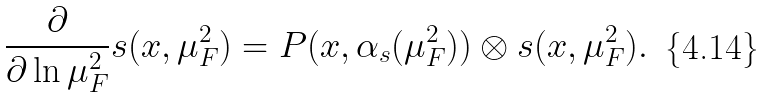Convert formula to latex. <formula><loc_0><loc_0><loc_500><loc_500>\frac { \partial } { \partial \ln \mu _ { F } ^ { 2 } } s ( x , \mu _ { F } ^ { 2 } ) = P ( x , \alpha _ { s } ( \mu _ { F } ^ { 2 } ) ) \otimes s ( x , \mu _ { F } ^ { 2 } ) .</formula> 